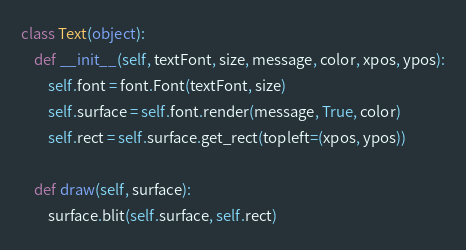<code> <loc_0><loc_0><loc_500><loc_500><_Python_>class Text(object):
    def __init__(self, textFont, size, message, color, xpos, ypos):
        self.font = font.Font(textFont, size)
        self.surface = self.font.render(message, True, color)
        self.rect = self.surface.get_rect(topleft=(xpos, ypos))

    def draw(self, surface):
        surface.blit(self.surface, self.rect)
</code> 